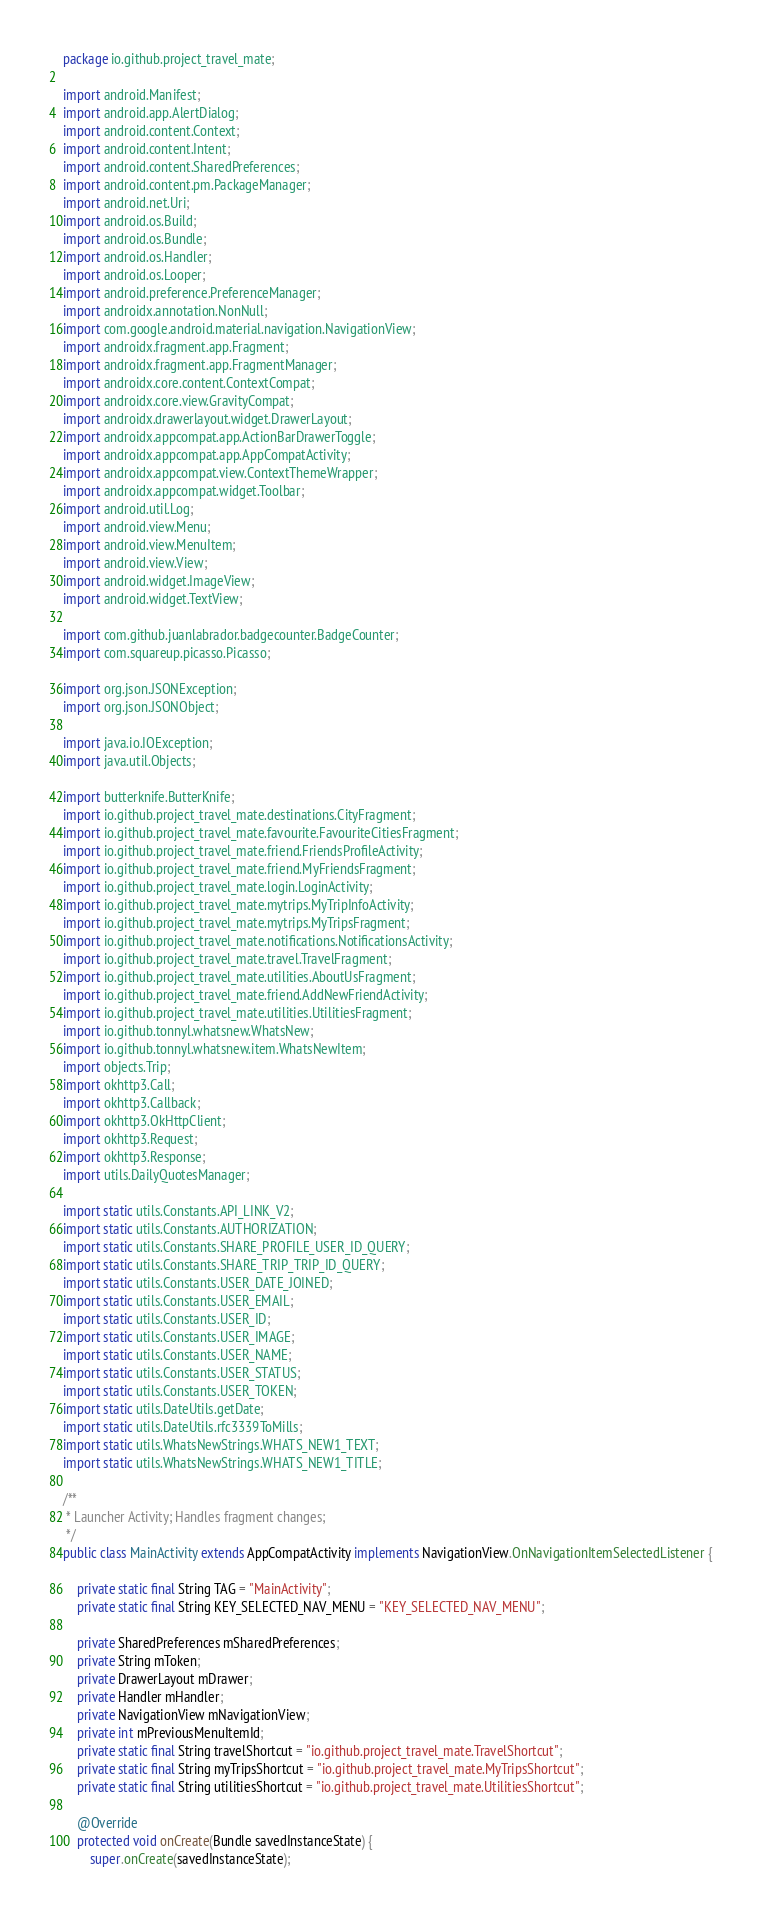Convert code to text. <code><loc_0><loc_0><loc_500><loc_500><_Java_>package io.github.project_travel_mate;

import android.Manifest;
import android.app.AlertDialog;
import android.content.Context;
import android.content.Intent;
import android.content.SharedPreferences;
import android.content.pm.PackageManager;
import android.net.Uri;
import android.os.Build;
import android.os.Bundle;
import android.os.Handler;
import android.os.Looper;
import android.preference.PreferenceManager;
import androidx.annotation.NonNull;
import com.google.android.material.navigation.NavigationView;
import androidx.fragment.app.Fragment;
import androidx.fragment.app.FragmentManager;
import androidx.core.content.ContextCompat;
import androidx.core.view.GravityCompat;
import androidx.drawerlayout.widget.DrawerLayout;
import androidx.appcompat.app.ActionBarDrawerToggle;
import androidx.appcompat.app.AppCompatActivity;
import androidx.appcompat.view.ContextThemeWrapper;
import androidx.appcompat.widget.Toolbar;
import android.util.Log;
import android.view.Menu;
import android.view.MenuItem;
import android.view.View;
import android.widget.ImageView;
import android.widget.TextView;

import com.github.juanlabrador.badgecounter.BadgeCounter;
import com.squareup.picasso.Picasso;

import org.json.JSONException;
import org.json.JSONObject;

import java.io.IOException;
import java.util.Objects;

import butterknife.ButterKnife;
import io.github.project_travel_mate.destinations.CityFragment;
import io.github.project_travel_mate.favourite.FavouriteCitiesFragment;
import io.github.project_travel_mate.friend.FriendsProfileActivity;
import io.github.project_travel_mate.friend.MyFriendsFragment;
import io.github.project_travel_mate.login.LoginActivity;
import io.github.project_travel_mate.mytrips.MyTripInfoActivity;
import io.github.project_travel_mate.mytrips.MyTripsFragment;
import io.github.project_travel_mate.notifications.NotificationsActivity;
import io.github.project_travel_mate.travel.TravelFragment;
import io.github.project_travel_mate.utilities.AboutUsFragment;
import io.github.project_travel_mate.friend.AddNewFriendActivity;
import io.github.project_travel_mate.utilities.UtilitiesFragment;
import io.github.tonnyl.whatsnew.WhatsNew;
import io.github.tonnyl.whatsnew.item.WhatsNewItem;
import objects.Trip;
import okhttp3.Call;
import okhttp3.Callback;
import okhttp3.OkHttpClient;
import okhttp3.Request;
import okhttp3.Response;
import utils.DailyQuotesManager;

import static utils.Constants.API_LINK_V2;
import static utils.Constants.AUTHORIZATION;
import static utils.Constants.SHARE_PROFILE_USER_ID_QUERY;
import static utils.Constants.SHARE_TRIP_TRIP_ID_QUERY;
import static utils.Constants.USER_DATE_JOINED;
import static utils.Constants.USER_EMAIL;
import static utils.Constants.USER_ID;
import static utils.Constants.USER_IMAGE;
import static utils.Constants.USER_NAME;
import static utils.Constants.USER_STATUS;
import static utils.Constants.USER_TOKEN;
import static utils.DateUtils.getDate;
import static utils.DateUtils.rfc3339ToMills;
import static utils.WhatsNewStrings.WHATS_NEW1_TEXT;
import static utils.WhatsNewStrings.WHATS_NEW1_TITLE;

/**
 * Launcher Activity; Handles fragment changes;
 */
public class MainActivity extends AppCompatActivity implements NavigationView.OnNavigationItemSelectedListener {

    private static final String TAG = "MainActivity";
    private static final String KEY_SELECTED_NAV_MENU = "KEY_SELECTED_NAV_MENU";

    private SharedPreferences mSharedPreferences;
    private String mToken;
    private DrawerLayout mDrawer;
    private Handler mHandler;
    private NavigationView mNavigationView;
    private int mPreviousMenuItemId;
    private static final String travelShortcut = "io.github.project_travel_mate.TravelShortcut";
    private static final String myTripsShortcut = "io.github.project_travel_mate.MyTripsShortcut";
    private static final String utilitiesShortcut = "io.github.project_travel_mate.UtilitiesShortcut";

    @Override
    protected void onCreate(Bundle savedInstanceState) {
        super.onCreate(savedInstanceState);</code> 